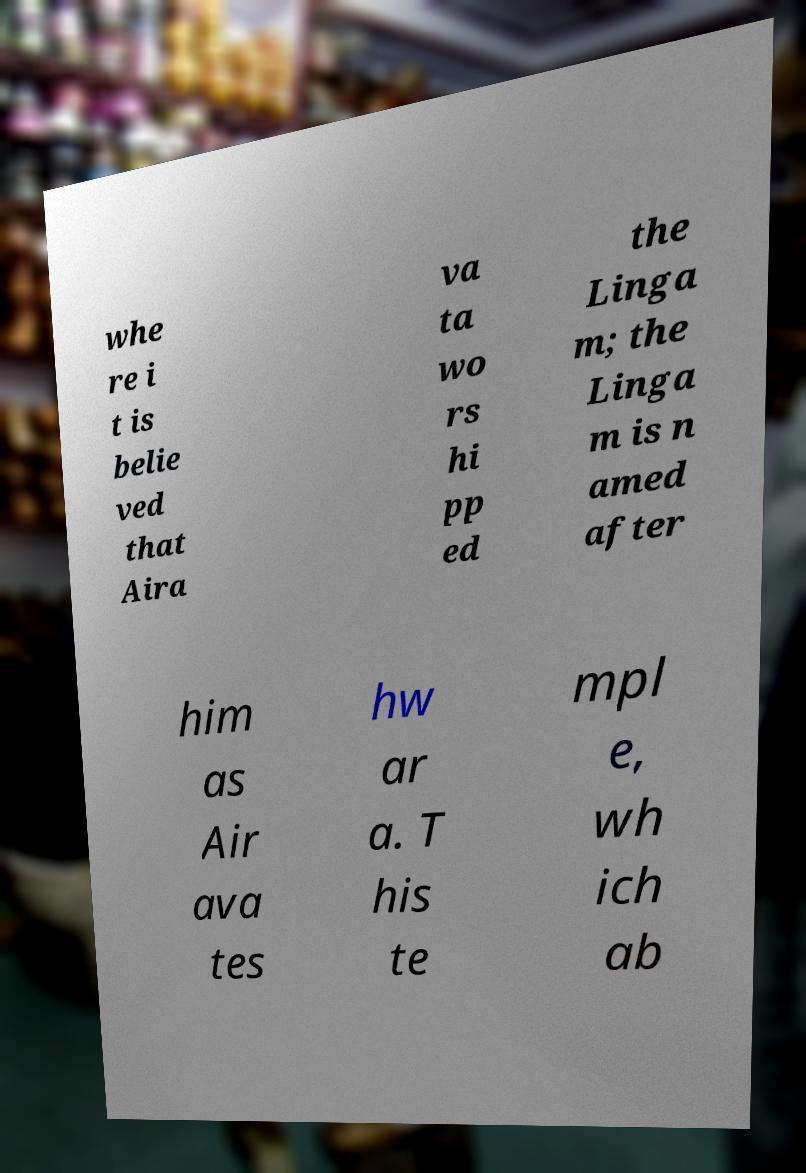Could you assist in decoding the text presented in this image and type it out clearly? whe re i t is belie ved that Aira va ta wo rs hi pp ed the Linga m; the Linga m is n amed after him as Air ava tes hw ar a. T his te mpl e, wh ich ab 